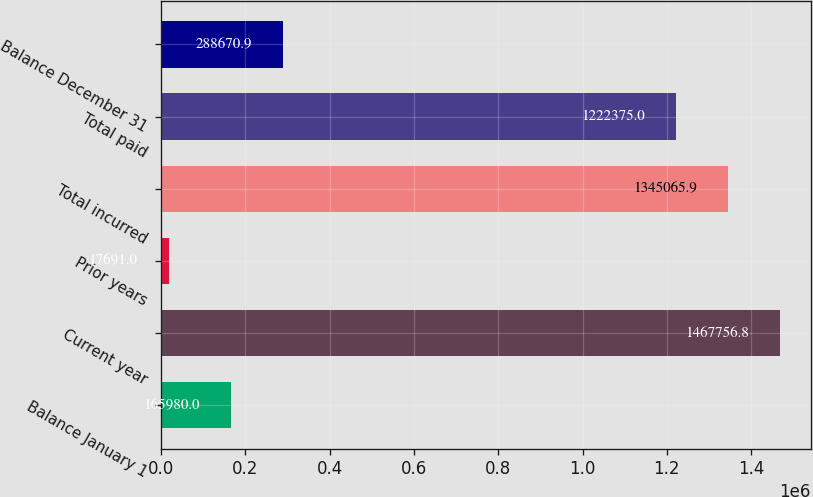<chart> <loc_0><loc_0><loc_500><loc_500><bar_chart><fcel>Balance January 1<fcel>Current year<fcel>Prior years<fcel>Total incurred<fcel>Total paid<fcel>Balance December 31<nl><fcel>165980<fcel>1.46776e+06<fcel>17691<fcel>1.34507e+06<fcel>1.22238e+06<fcel>288671<nl></chart> 